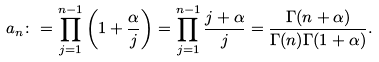<formula> <loc_0><loc_0><loc_500><loc_500>a _ { n } \colon = \prod _ { j = 1 } ^ { n - 1 } \left ( 1 + \frac { \alpha } { j } \right ) = \prod _ { j = 1 } ^ { n - 1 } \frac { j + \alpha } { j } = \frac { \Gamma ( n + \alpha ) } { \Gamma ( n ) \Gamma ( 1 + \alpha ) } .</formula> 